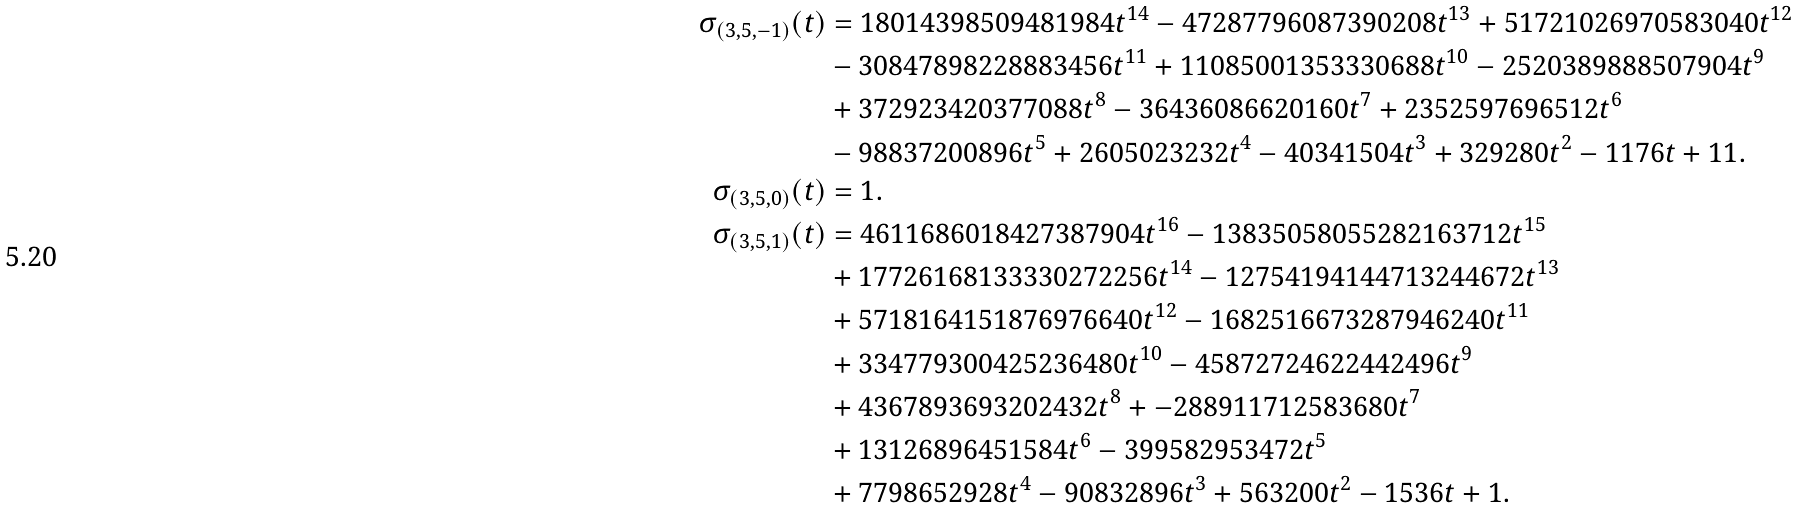<formula> <loc_0><loc_0><loc_500><loc_500>\sigma _ { ( 3 , 5 , - 1 ) } ( t ) & = 1 8 0 1 4 3 9 8 5 0 9 4 8 1 9 8 4 t ^ { 1 4 } - 4 7 2 8 7 7 9 6 0 8 7 3 9 0 2 0 8 t ^ { 1 3 } + 5 1 7 2 1 0 2 6 9 7 0 5 8 3 0 4 0 t ^ { 1 2 } \\ & - 3 0 8 4 7 8 9 8 2 2 8 8 8 3 4 5 6 t ^ { 1 1 } + 1 1 0 8 5 0 0 1 3 5 3 3 3 0 6 8 8 t ^ { 1 0 } - 2 5 2 0 3 8 9 8 8 8 5 0 7 9 0 4 t ^ { 9 } \\ & + 3 7 2 9 2 3 4 2 0 3 7 7 0 8 8 t ^ { 8 } - 3 6 4 3 6 0 8 6 6 2 0 1 6 0 t ^ { 7 } + 2 3 5 2 5 9 7 6 9 6 5 1 2 t ^ { 6 } \\ & - 9 8 8 3 7 2 0 0 8 9 6 t ^ { 5 } + 2 6 0 5 0 2 3 2 3 2 t ^ { 4 } - 4 0 3 4 1 5 0 4 t ^ { 3 } + 3 2 9 2 8 0 t ^ { 2 } - 1 1 7 6 t + 1 1 . \\ \sigma _ { ( 3 , 5 , 0 ) } ( t ) & = 1 . \\ \sigma _ { ( 3 , 5 , 1 ) } ( t ) & = 4 6 1 1 6 8 6 0 1 8 4 2 7 3 8 7 9 0 4 t ^ { 1 6 } - 1 3 8 3 5 0 5 8 0 5 5 2 8 2 1 6 3 7 1 2 t ^ { 1 5 } \\ & + 1 7 7 2 6 1 6 8 1 3 3 3 3 0 2 7 2 2 5 6 t ^ { 1 4 } - 1 2 7 5 4 1 9 4 1 4 4 7 1 3 2 4 4 6 7 2 t ^ { 1 3 } \\ & + 5 7 1 8 1 6 4 1 5 1 8 7 6 9 7 6 6 4 0 t ^ { 1 2 } - 1 6 8 2 5 1 6 6 7 3 2 8 7 9 4 6 2 4 0 t ^ { 1 1 } \\ & + 3 3 4 7 7 9 3 0 0 4 2 5 2 3 6 4 8 0 t ^ { 1 0 } - 4 5 8 7 2 7 2 4 6 2 2 4 4 2 4 9 6 t ^ { 9 } \\ & + 4 3 6 7 8 9 3 6 9 3 2 0 2 4 3 2 t ^ { 8 } + - 2 8 8 9 1 1 7 1 2 5 8 3 6 8 0 t ^ { 7 } \\ & + 1 3 1 2 6 8 9 6 4 5 1 5 8 4 t ^ { 6 } - 3 9 9 5 8 2 9 5 3 4 7 2 t ^ { 5 } \\ & + 7 7 9 8 6 5 2 9 2 8 t ^ { 4 } - 9 0 8 3 2 8 9 6 t ^ { 3 } + 5 6 3 2 0 0 t ^ { 2 } - 1 5 3 6 t + 1 .</formula> 